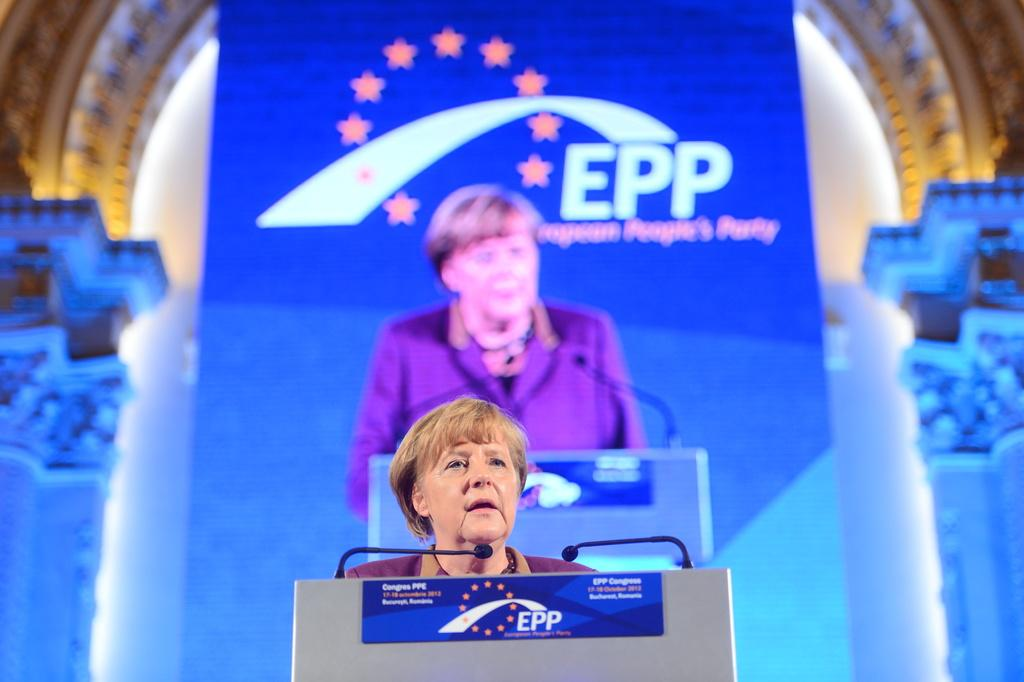What is the person in the image doing? The person is standing in front of a podium. What equipment is visible in the image for amplifying sound? There are two microphones in the image. What is attached to the podium? There is a blue color board attached to the podium. What color board is visible in the background? There is a blue and white color board visible in the background. What type of stew is being served at the camp in the image? There is no camp or stew present in the image; it features a person standing in front of a podium with microphones and color boards. What advice is the father giving to the audience in the image? There is no father or audience present in the image; it only shows a person standing in front of a podium with microphones and color boards. 